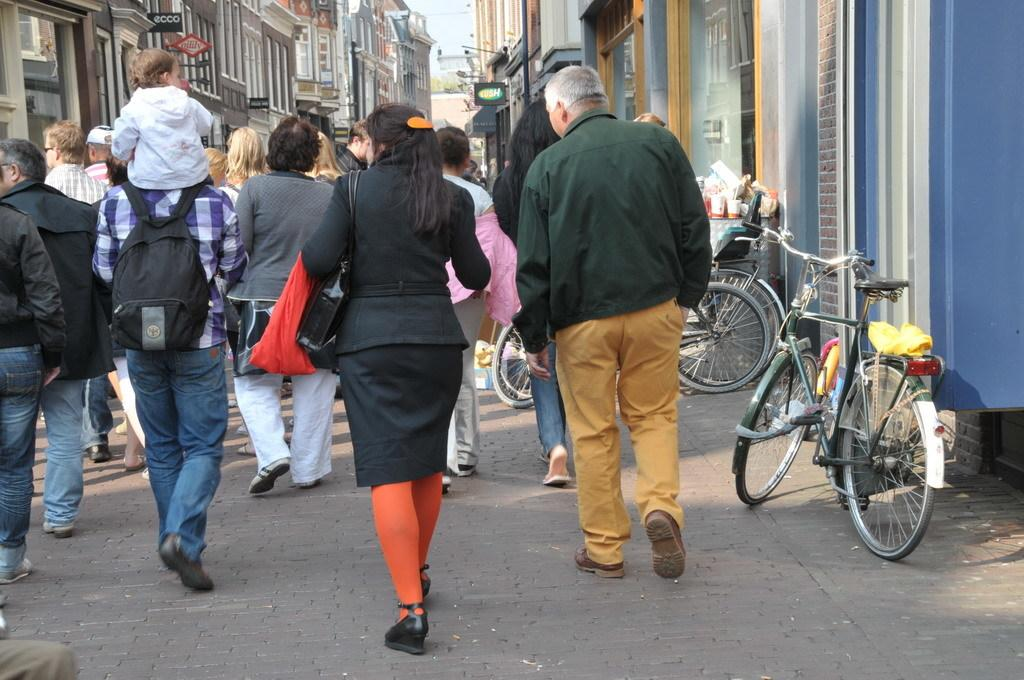What are the people in the image doing? The people in the image are walking on the road. What else can be seen on the road in the image? Vehicles are visible in the image. What is the surrounding environment like in the image? There are buildings around in the image. What type of tin can be seen on top of the buildings in the image? There is no tin visible on top of the buildings in the image. Are there any bananas hanging from the trees in the image? There are no trees or bananas present in the image. 